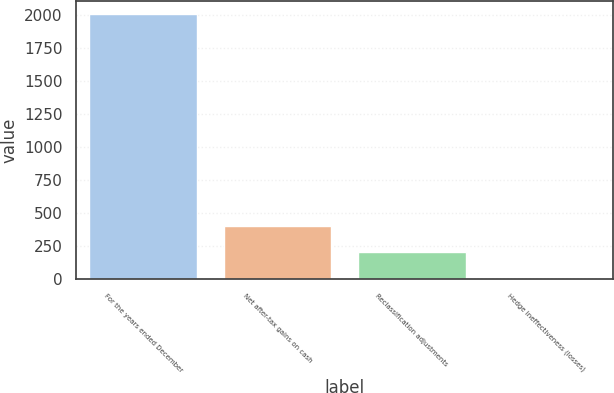Convert chart. <chart><loc_0><loc_0><loc_500><loc_500><bar_chart><fcel>For the years ended December<fcel>Net after-tax gains on cash<fcel>Reclassification adjustments<fcel>Hedge ineffectiveness (losses)<nl><fcel>2006<fcel>402.8<fcel>202.4<fcel>2<nl></chart> 